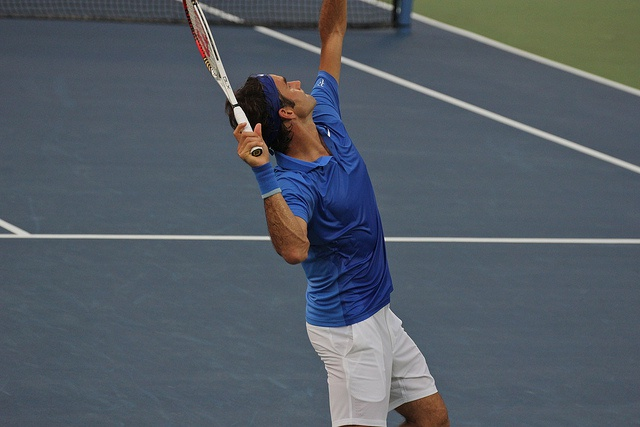Describe the objects in this image and their specific colors. I can see people in black, navy, darkgray, and blue tones and tennis racket in black, lightgray, darkgray, and gray tones in this image. 